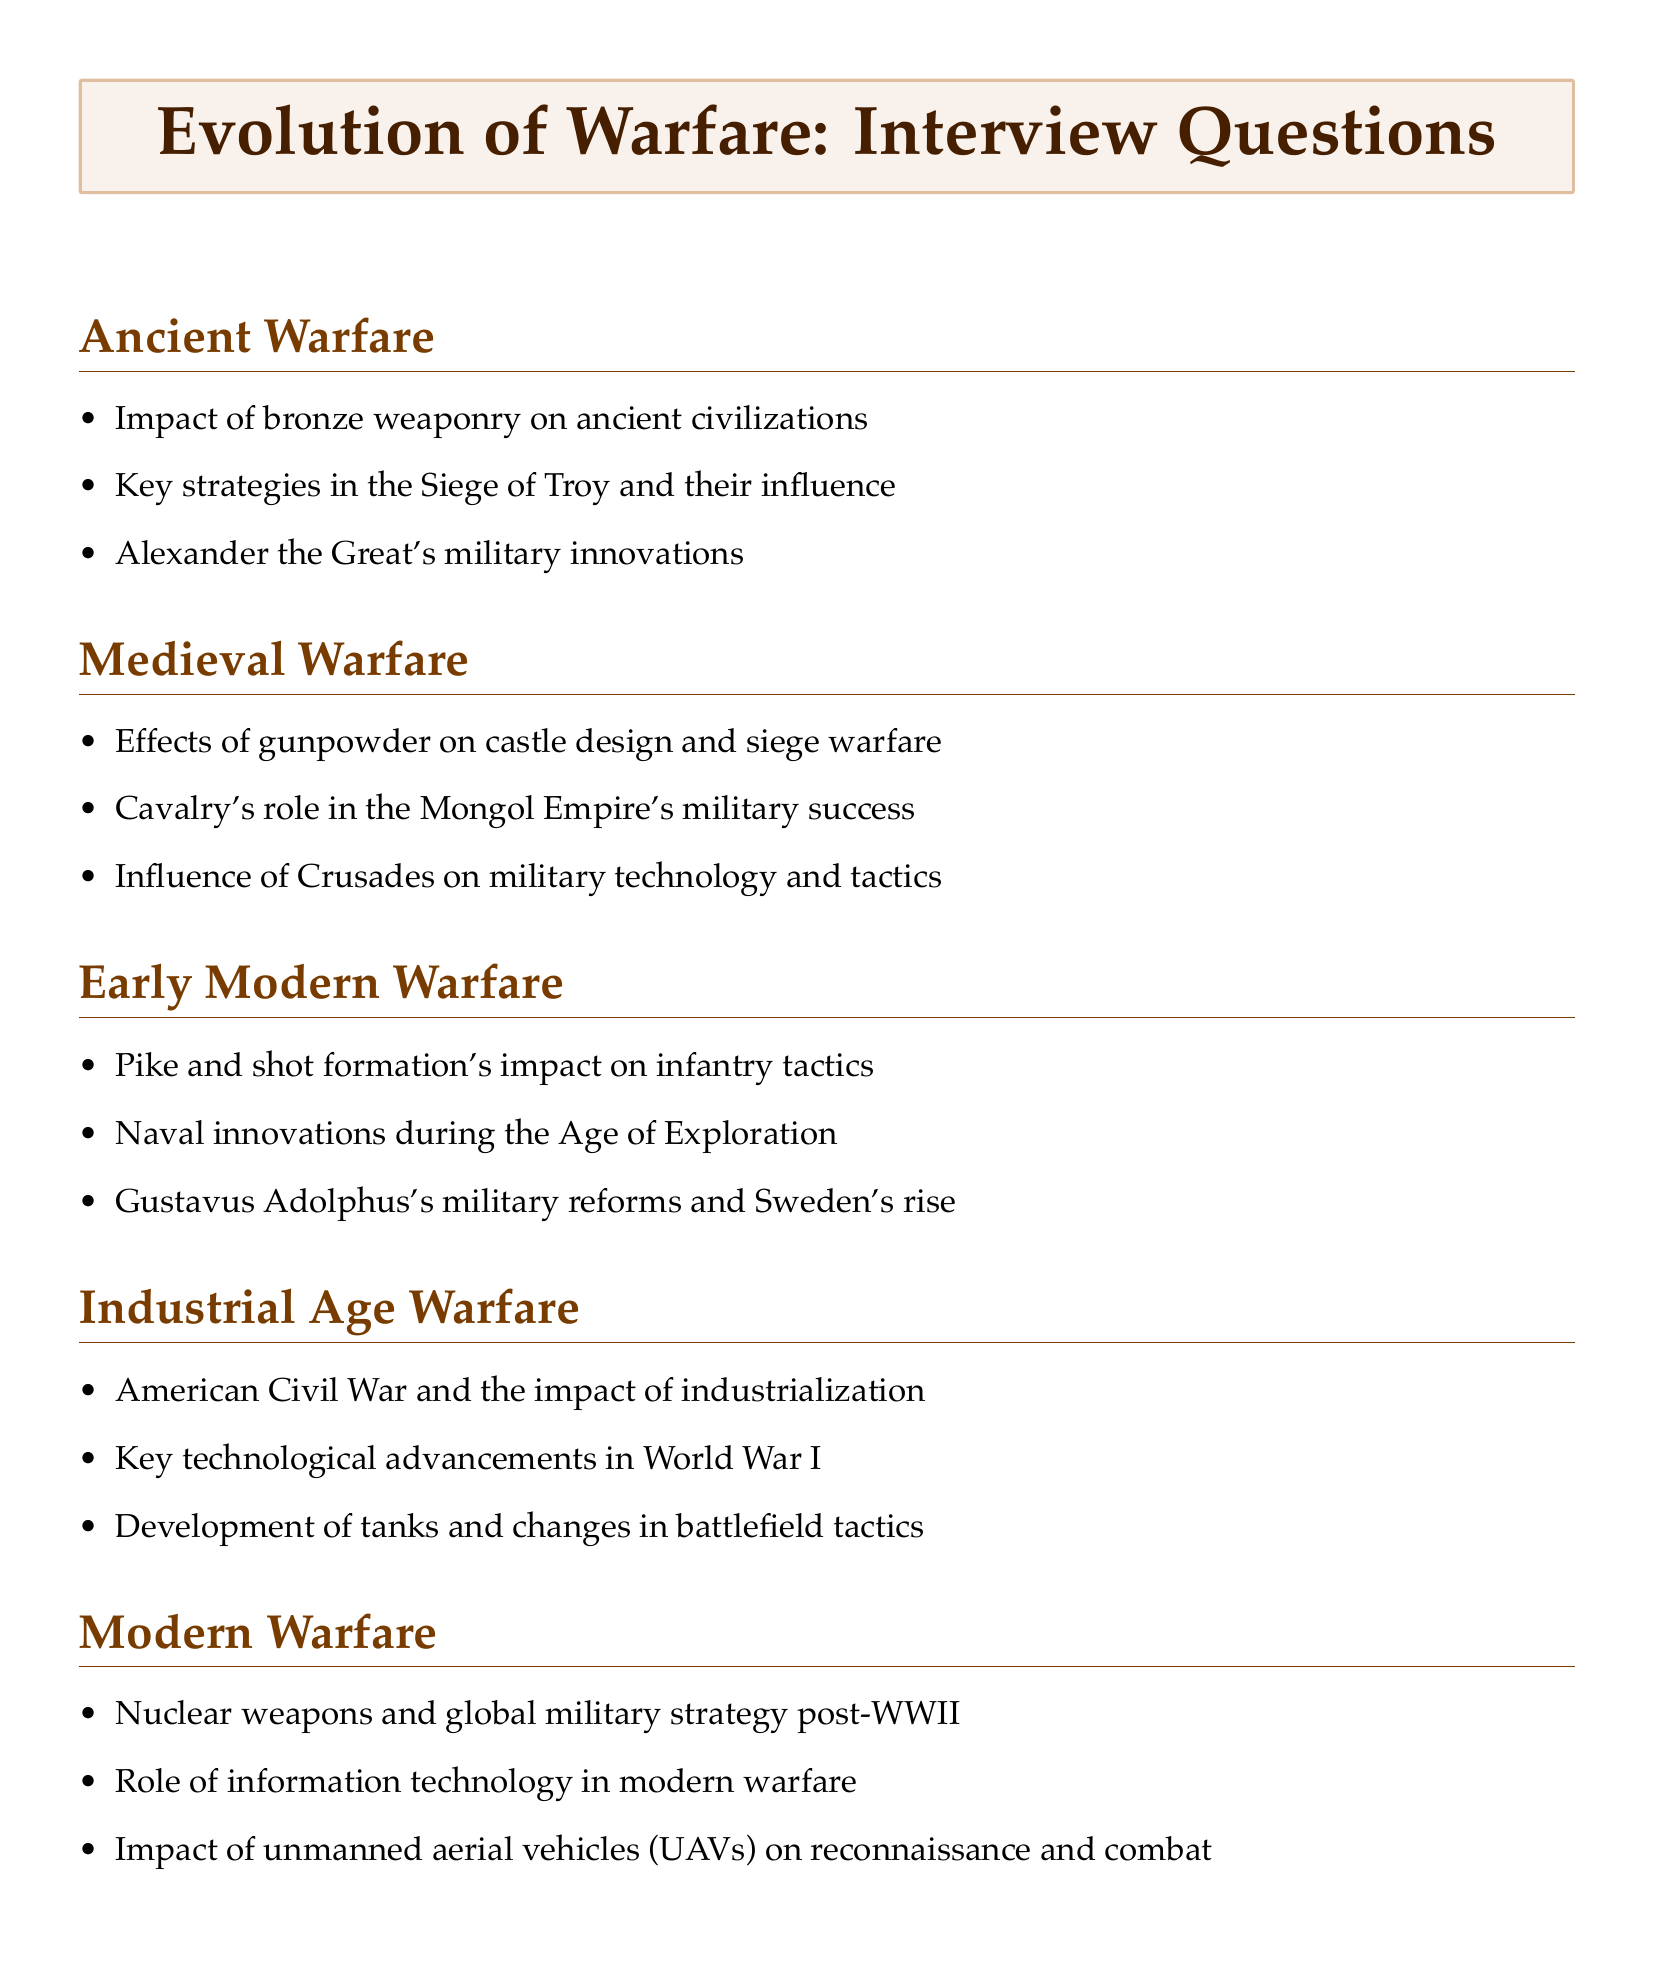How many categories of warfare are discussed in the document? The document presents five distinct categories of warfare: Ancient, Medieval, Early Modern, Industrial Age, and Modern.
Answer: 5 What is one of the key strategies employed in the Siege of Troy? The document lists the strategies used in the Siege of Troy, which are important for understanding their influence on future siege tactics.
Answer: Siege tactics Which weaponry development is mentioned as having an impact on ancient civilizations? The document identifies the development of bronze weaponry as a significant factor affecting warfare in ancient times.
Answer: Bronze weaponry What technological advancement shaped World War I according to the document? The document highlights that key technological advancements during World War I influenced the nature and outcomes of the conflict.
Answer: Technological advancements What role did cavalry play in the military success of which empire? The document notes that cavalry was essential to the military success of the Mongol Empire under Genghis Khan.
Answer: Mongol Empire Which formation revolutionized infantry tactics in the 16th and 17th centuries? The pike and shot formation is specifically mentioned as a revolutionary tactic in the document.
Answer: Pike and shot formation What impact did nuclear weapons have on military strategy post-World War II? The document states that the advent of nuclear weapons significantly altered global military strategy following World War II.
Answer: Altered global military strategy What was the significance of the American Civil War in relation to industrialization? The document indicates that the American Civil War served as a demonstration of the impact industrialization had on warfare.
Answer: Impact of industrialization Which vehicle type has changed reconnaissance and combat in recent conflicts? The document refers to unmanned aerial vehicles (UAVs) as changing the nature of reconnaissance and combat in recent conflicts.
Answer: Unmanned aerial vehicles 